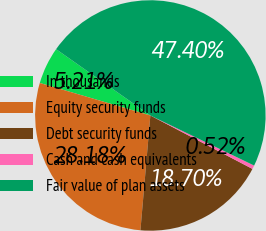Convert chart to OTSL. <chart><loc_0><loc_0><loc_500><loc_500><pie_chart><fcel>In thousands<fcel>Equity security funds<fcel>Debt security funds<fcel>Cash and cash equivalents<fcel>Fair value of plan assets<nl><fcel>5.21%<fcel>28.18%<fcel>18.7%<fcel>0.52%<fcel>47.4%<nl></chart> 